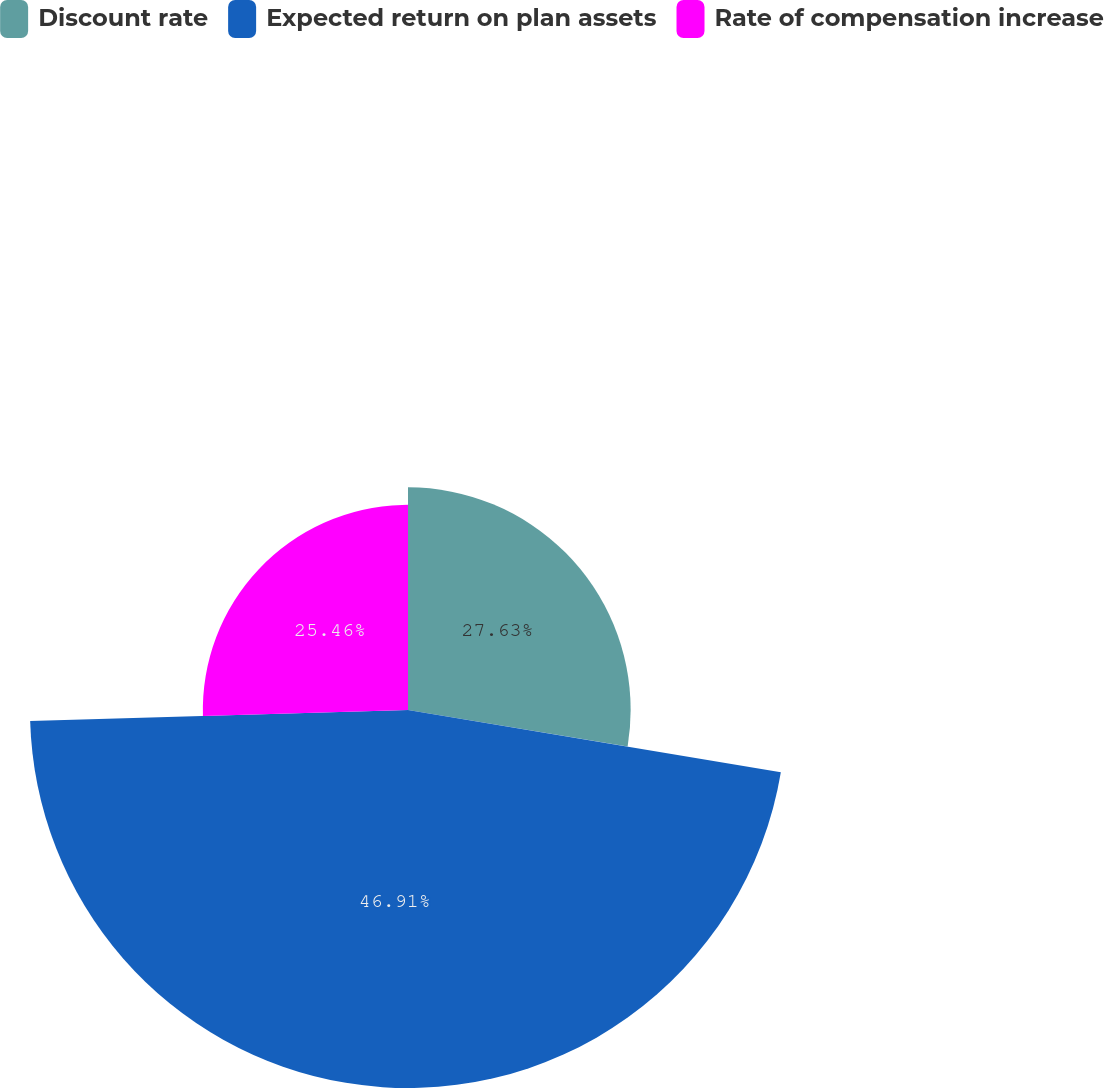<chart> <loc_0><loc_0><loc_500><loc_500><pie_chart><fcel>Discount rate<fcel>Expected return on plan assets<fcel>Rate of compensation increase<nl><fcel>27.63%<fcel>46.91%<fcel>25.46%<nl></chart> 